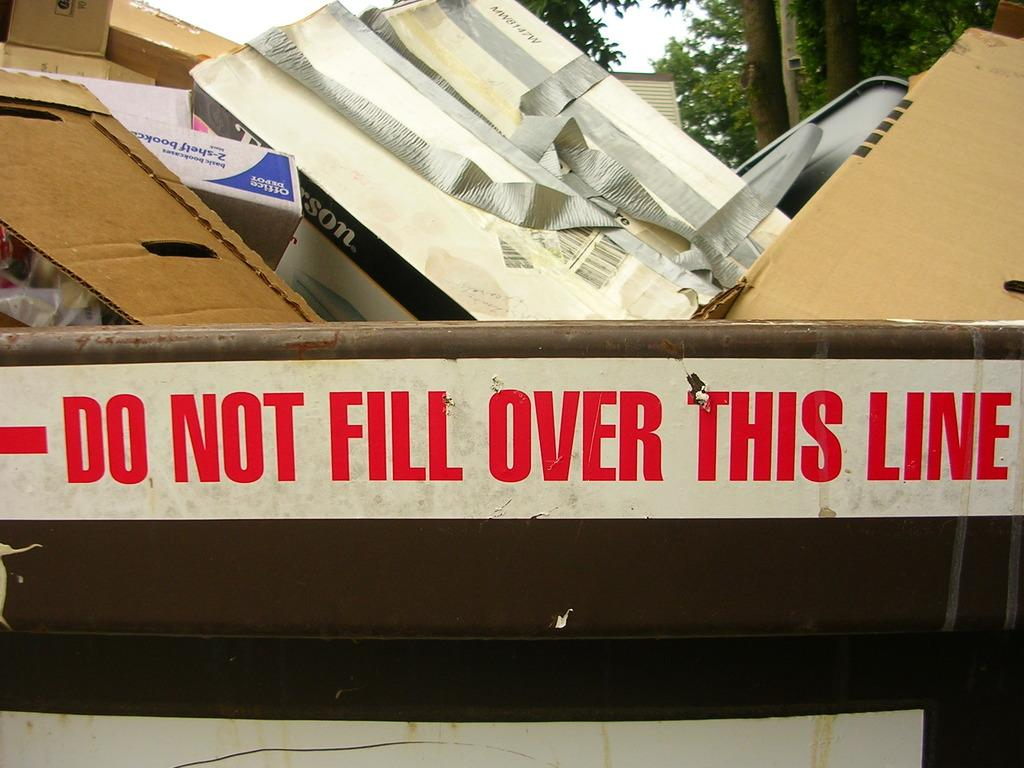<image>
Share a concise interpretation of the image provided. Trash can with a Do Not Fill Over This Line sign. 